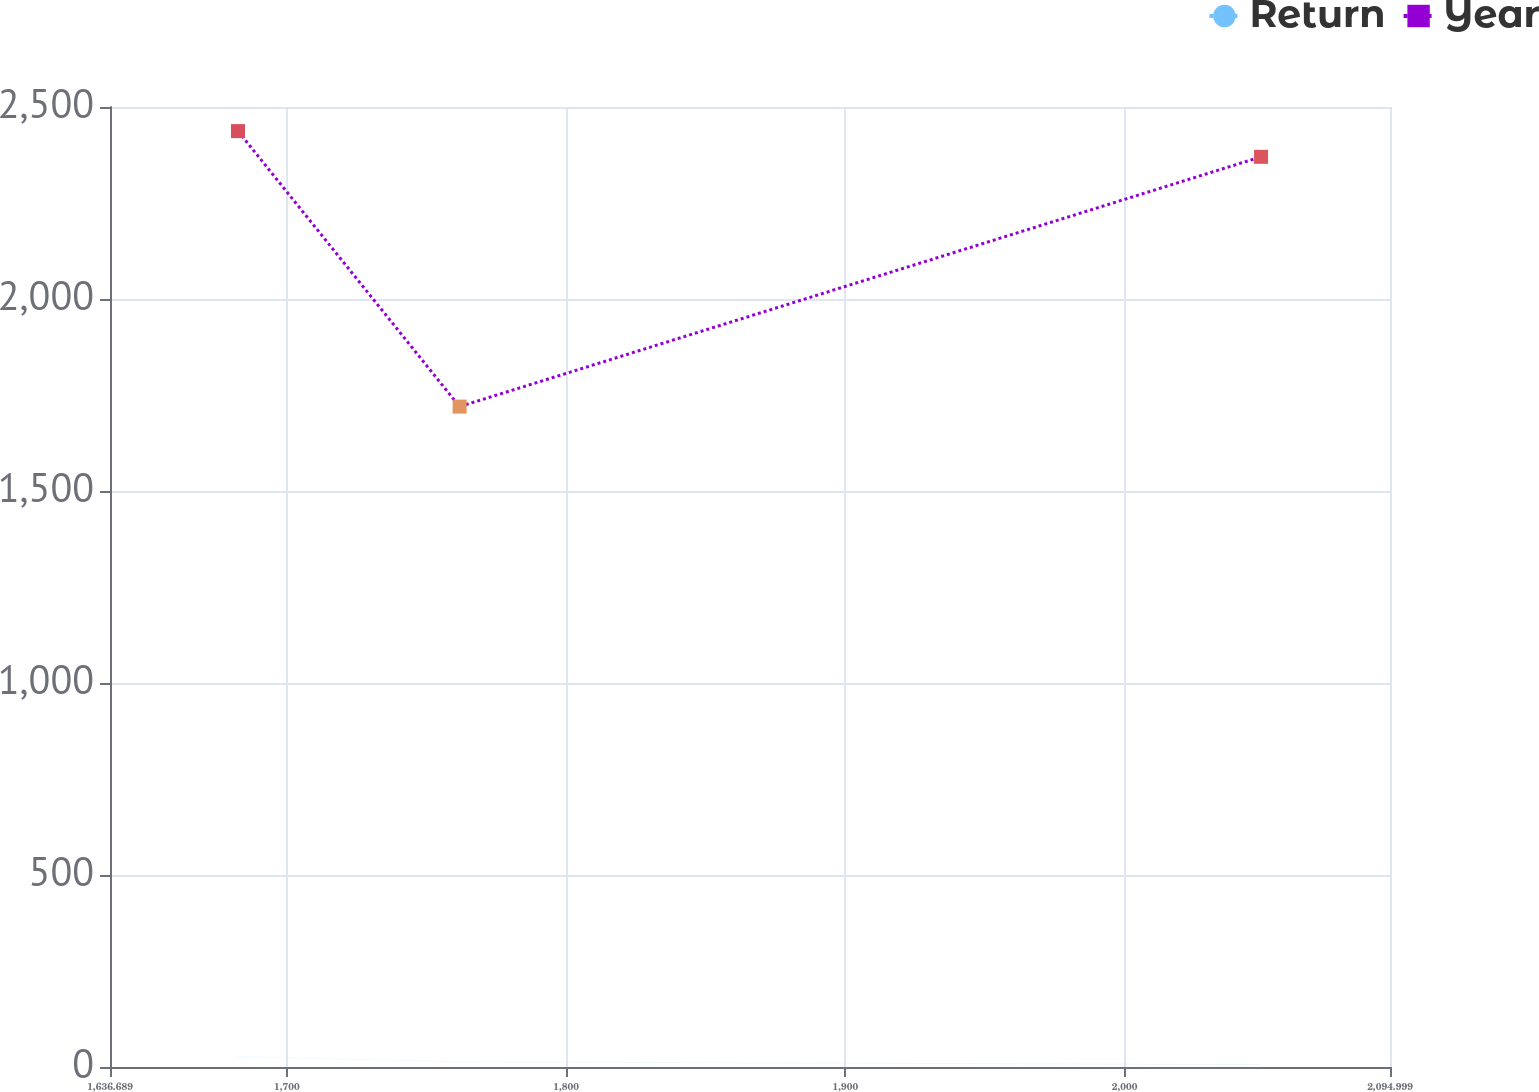<chart> <loc_0><loc_0><loc_500><loc_500><line_chart><ecel><fcel>Return<fcel>Year<nl><fcel>1682.52<fcel>27.32<fcel>2437.18<nl><fcel>1761.87<fcel>13.4<fcel>1719.77<nl><fcel>2048.83<fcel>6.23<fcel>2370.22<nl><fcel>2098.1<fcel>2.95<fcel>1898.84<nl><fcel>2140.83<fcel>19.44<fcel>2054.65<nl></chart> 